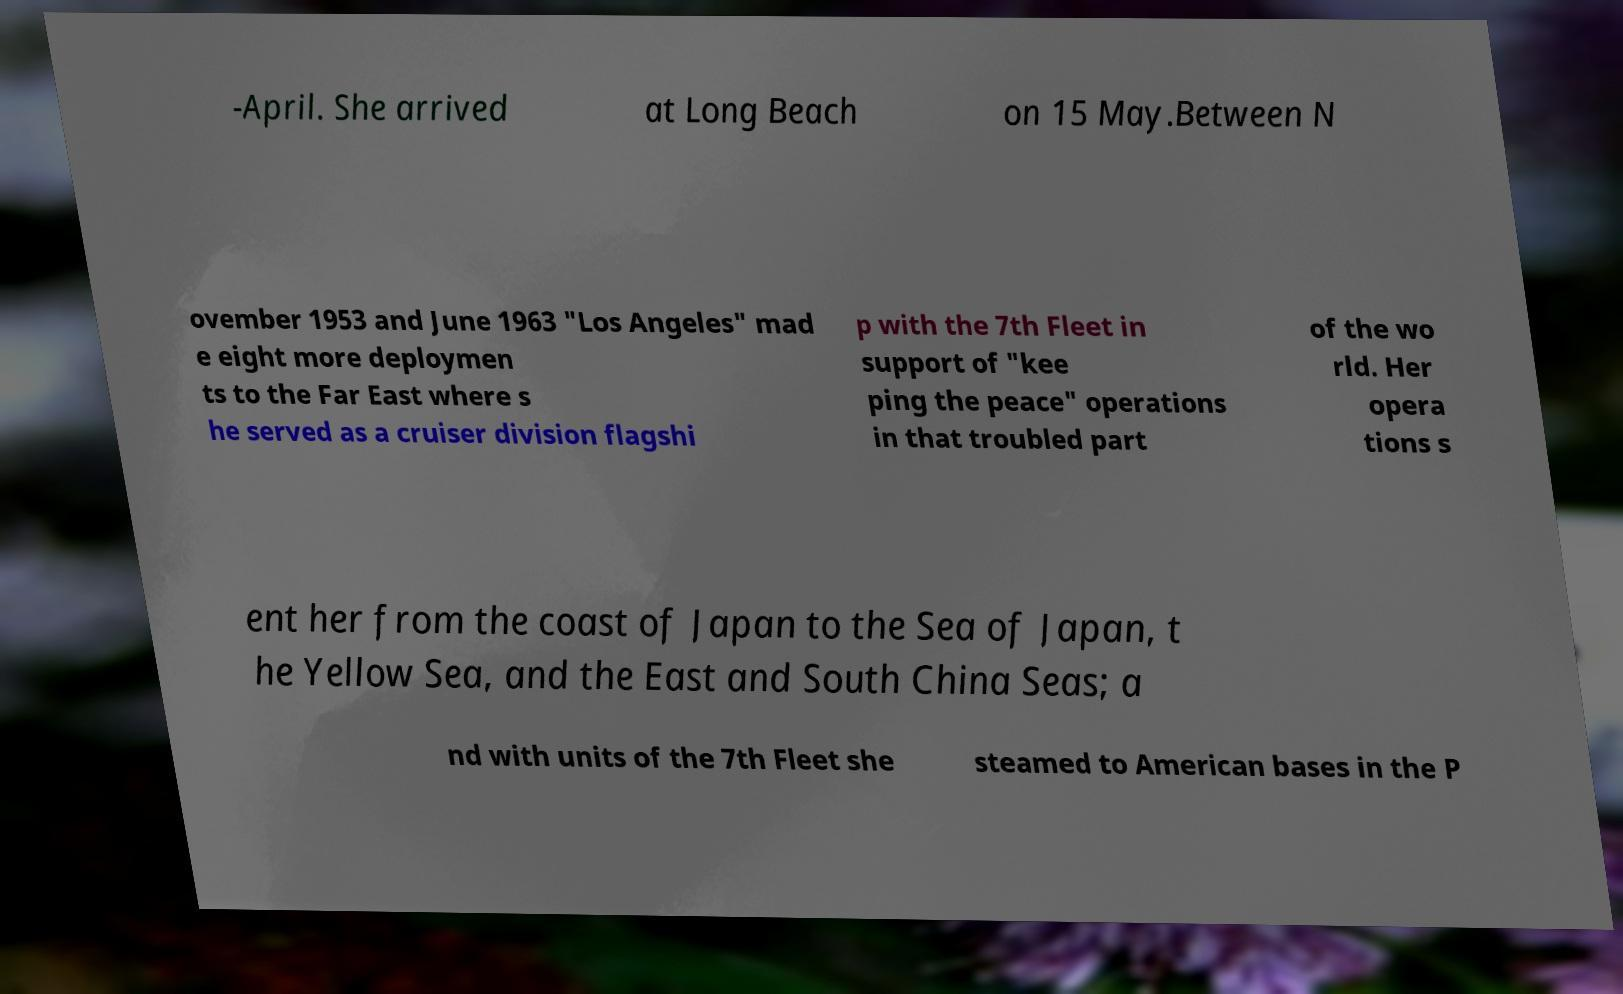What messages or text are displayed in this image? I need them in a readable, typed format. -April. She arrived at Long Beach on 15 May.Between N ovember 1953 and June 1963 "Los Angeles" mad e eight more deploymen ts to the Far East where s he served as a cruiser division flagshi p with the 7th Fleet in support of "kee ping the peace" operations in that troubled part of the wo rld. Her opera tions s ent her from the coast of Japan to the Sea of Japan, t he Yellow Sea, and the East and South China Seas; a nd with units of the 7th Fleet she steamed to American bases in the P 